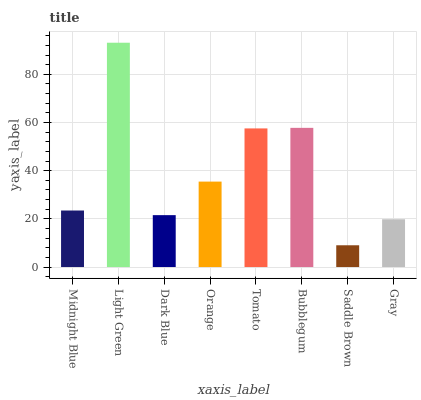Is Saddle Brown the minimum?
Answer yes or no. Yes. Is Light Green the maximum?
Answer yes or no. Yes. Is Dark Blue the minimum?
Answer yes or no. No. Is Dark Blue the maximum?
Answer yes or no. No. Is Light Green greater than Dark Blue?
Answer yes or no. Yes. Is Dark Blue less than Light Green?
Answer yes or no. Yes. Is Dark Blue greater than Light Green?
Answer yes or no. No. Is Light Green less than Dark Blue?
Answer yes or no. No. Is Orange the high median?
Answer yes or no. Yes. Is Midnight Blue the low median?
Answer yes or no. Yes. Is Saddle Brown the high median?
Answer yes or no. No. Is Gray the low median?
Answer yes or no. No. 